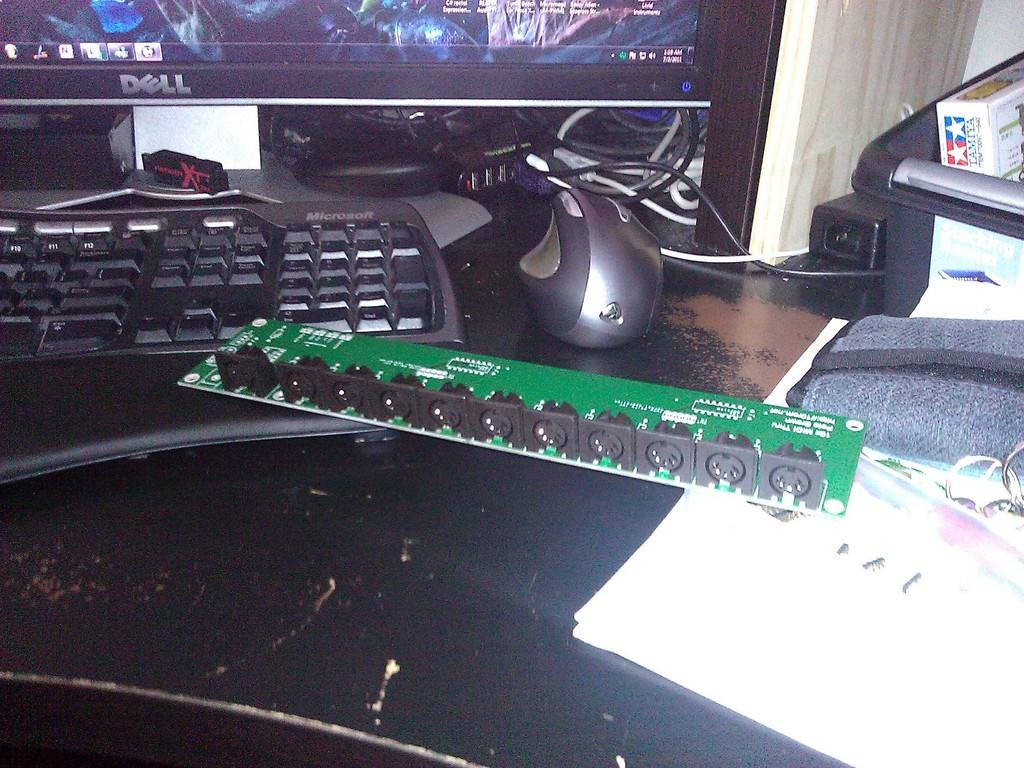What is the main object in the center of the image? There is a table in the center of the image. What electronic device can be seen on the table? A keyboard, a monitor, and a mouse are present on the table. Are there any other electronic devices on the table? Yes, there are other electronic devices on the table. What is located to the right side of the image? There is a book to the right side of the image. Reasoning: Let' Let's think step by step in order to produce the conversation. We start by identifying the main object in the image, which is the table. Then, we describe the electronic devices that are visible on the table, including the keyboard, monitor, and mouse. We also mention that there are other electronic devices present on the table. Finally, we identify the object located to the right side of the image, which is a book. Absurd Question/Answer: What type of loaf is being used to adjust the monitor's height in the image? There is no loaf present in the image, and the monitor's height is not being adjusted. 